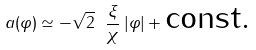Convert formula to latex. <formula><loc_0><loc_0><loc_500><loc_500>a ( \varphi ) \simeq - \sqrt { 2 } \ \frac { \xi } { \chi } \, | \varphi | + \text {const.}</formula> 